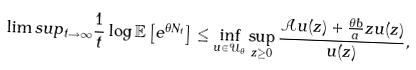Convert formula to latex. <formula><loc_0><loc_0><loc_500><loc_500>\lim s u p _ { t \rightarrow \infty } \frac { 1 } { t } \log \mathbb { E } \left [ e ^ { \theta N _ { t } } \right ] \leq \inf _ { u \in \mathcal { U } _ { \theta } } \sup _ { z \geq 0 } \frac { \mathcal { A } u ( z ) + \frac { \theta b } { a } z u ( z ) } { u ( z ) } ,</formula> 